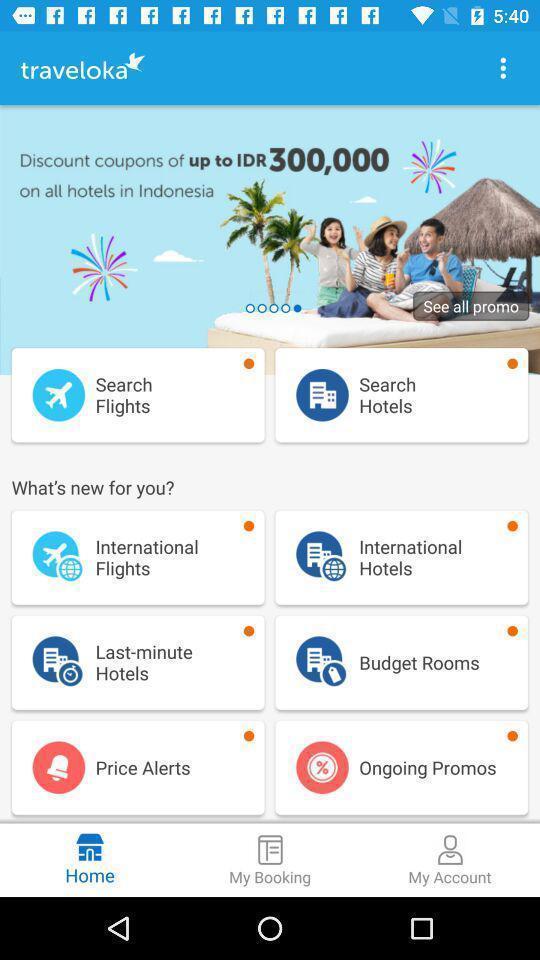Tell me about the visual elements in this screen capture. Welcome page for a travel planning app. 